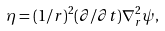<formula> <loc_0><loc_0><loc_500><loc_500>\eta = ( 1 / r ) ^ { 2 } ( \partial / \partial t ) \nabla _ { r } ^ { 2 } \psi ,</formula> 